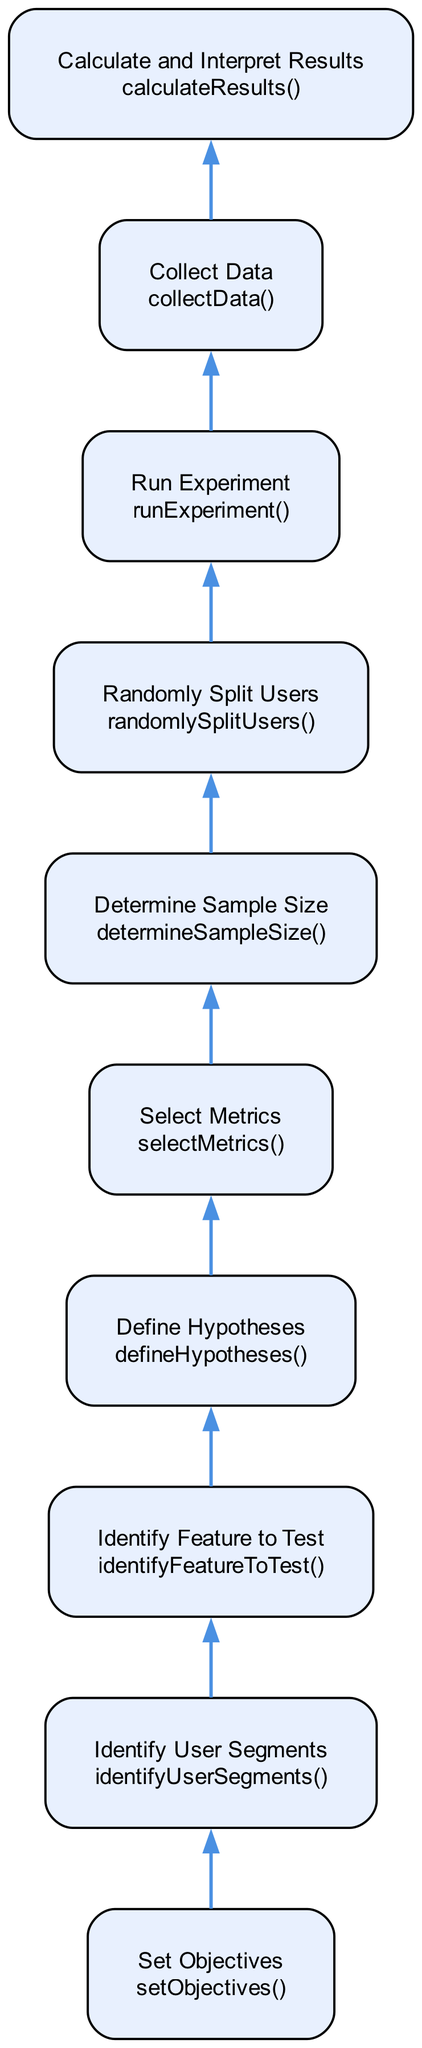What is the top node in the diagram? The top node in the diagram represents the final step of the process, which is "Calculate and Interpret Results". This indicates that after all preceding steps have been completed, the results are analyzed to determine the effectiveness of the A/B test.
Answer: Calculate and Interpret Results How many nodes are present in the diagram? To answer this, we count the distinct elements listed in the diagram. There are a total of ten nodes representing each step in the A/B testing workflow.
Answer: 10 What is the first action that starts the workflow? The first action that initiates the workflow is "Identify Feature to Test". This is the starting point where the new feature that will be evaluated is selected.
Answer: Identify Feature to Test What is the relationship between "Select Metrics" and "Define Hypotheses"? "Select Metrics" is positioned immediately above "Define Hypotheses" in the flow of the diagram. This indicates that metrics are chosen before formulating the hypotheses, as these metrics will guide what is being tested.
Answer: Select Metrics is above Define Hypotheses What are the two user groups split by the process? The process involves splitting users into two groups: one group for the control version and another group for the variant. This division is crucial for comparing the performance of the two versions.
Answer: Control version and Variant Which step immediately precedes "Run Experiment"? "Randomly Split Users" directly precedes "Run Experiment" in the flow of the diagram. This indicates that users must be divided into groups before the actual experiment is deployed.
Answer: Randomly Split Users What is the purpose of the "Determine Sample Size" step? This step is aimed at calculating how many users are needed for the A/B test to achieve statistically significant results. Its placement reflects that establishing a sample size is essential before splitting users.
Answer: Calculate the number of users needed What comes after "Collect Data" in the workflow? The step that follows "Collect Data" is "Calculate and Interpret Results". This shows that once data is gathered regarding user interactions, the next action is to analyze these results to check if there's a significant difference.
Answer: Calculate and Interpret Results What is the main focus of the "Set Objectives" step? The main focus of "Set Objectives" is to define the goals and objectives of the A/B test, such as improving user engagement or increasing conversion rates. This step sets the purpose for the entire testing process.
Answer: Define the goals and objectives 